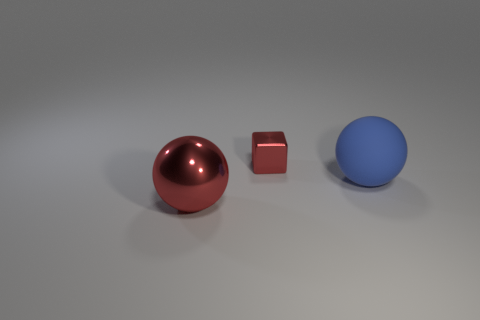Can you estimate the sizes of these objects relative to each other? Relatively speaking, the large red sphere appears to be the biggest object, followed by the blue ball which is smaller in scale. The block, though difficult to determine its exact dimensions without a reference, appears to be the smallest object among them. The proportions and perspective of the image suggest a descending order in size from the sphere, to the ball, and finally to the block. 